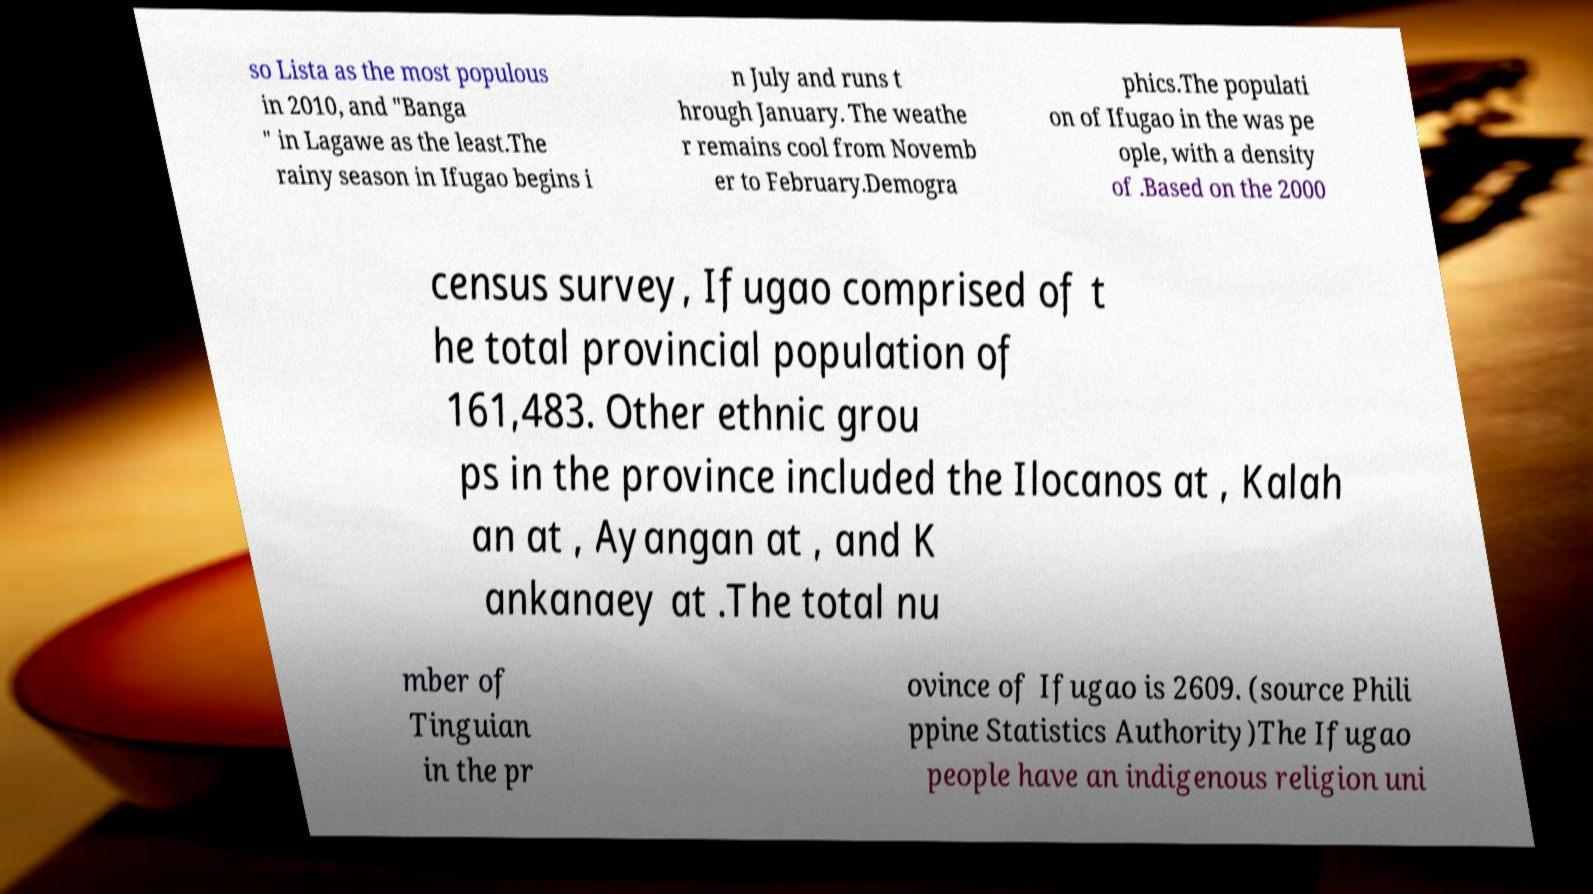Could you extract and type out the text from this image? so Lista as the most populous in 2010, and "Banga " in Lagawe as the least.The rainy season in Ifugao begins i n July and runs t hrough January. The weathe r remains cool from Novemb er to February.Demogra phics.The populati on of Ifugao in the was pe ople, with a density of .Based on the 2000 census survey, Ifugao comprised of t he total provincial population of 161,483. Other ethnic grou ps in the province included the Ilocanos at , Kalah an at , Ayangan at , and K ankanaey at .The total nu mber of Tinguian in the pr ovince of Ifugao is 2609. (source Phili ppine Statistics Authority)The Ifugao people have an indigenous religion uni 